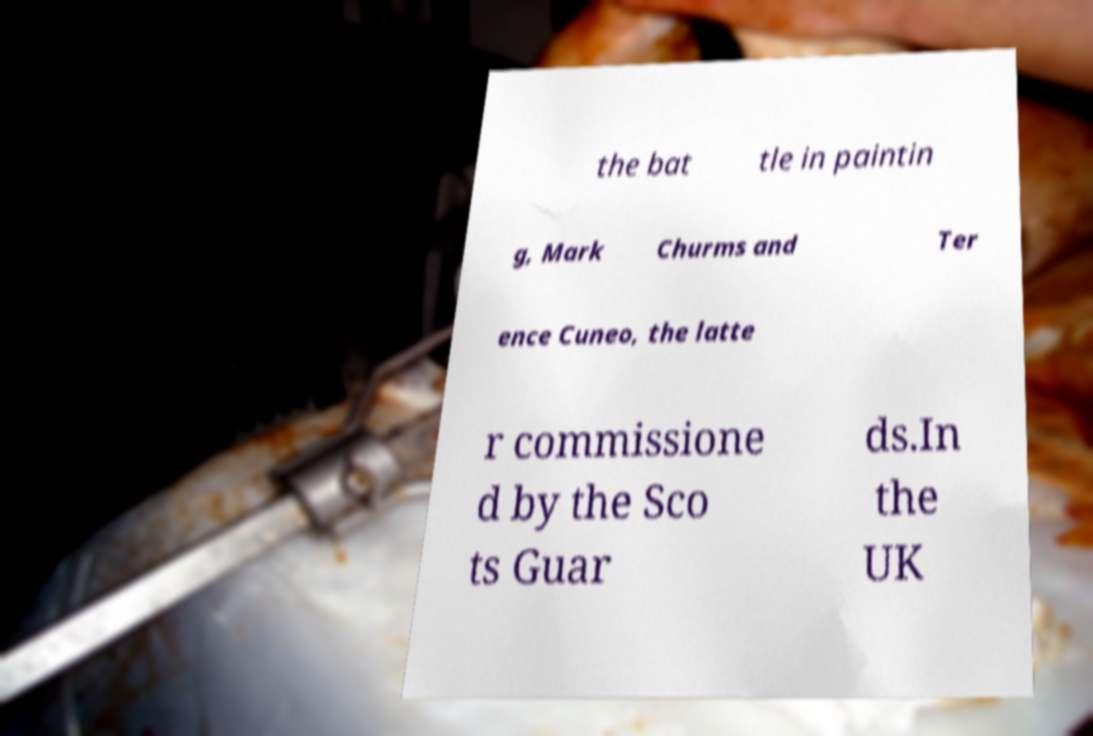Can you read and provide the text displayed in the image?This photo seems to have some interesting text. Can you extract and type it out for me? the bat tle in paintin g, Mark Churms and Ter ence Cuneo, the latte r commissione d by the Sco ts Guar ds.In the UK 